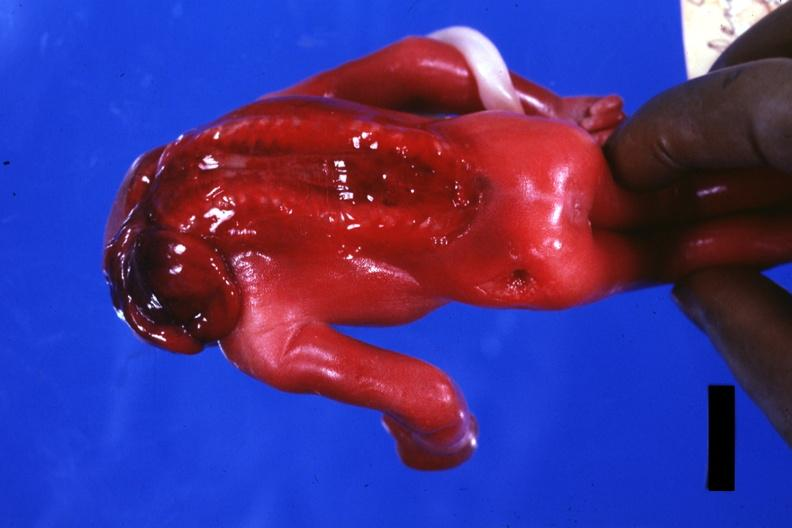what is present?
Answer the question using a single word or phrase. Anencephaly 